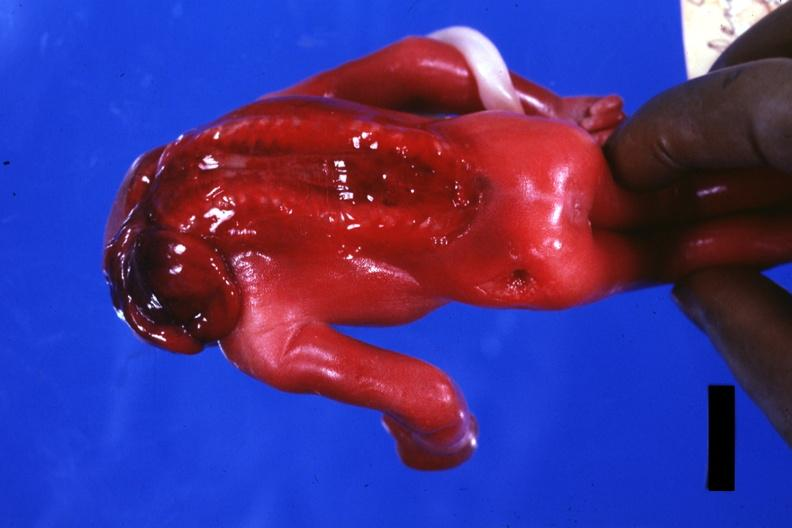what is present?
Answer the question using a single word or phrase. Anencephaly 